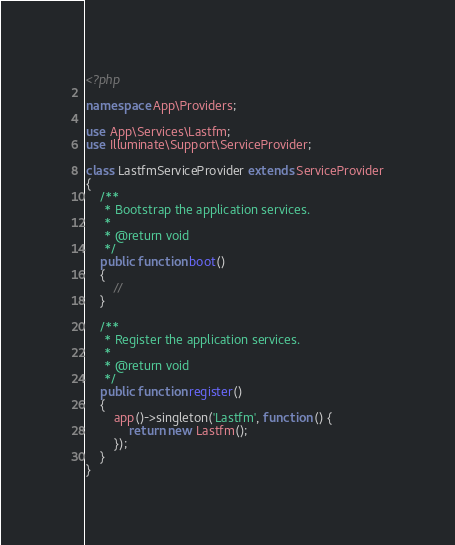Convert code to text. <code><loc_0><loc_0><loc_500><loc_500><_PHP_><?php

namespace App\Providers;

use App\Services\Lastfm;
use Illuminate\Support\ServiceProvider;

class LastfmServiceProvider extends ServiceProvider
{
    /**
     * Bootstrap the application services.
     *
     * @return void
     */
    public function boot()
    {
        //
    }

    /**
     * Register the application services.
     *
     * @return void
     */
    public function register()
    {
        app()->singleton('Lastfm', function () {
            return new Lastfm();
        });
    }
}
</code> 